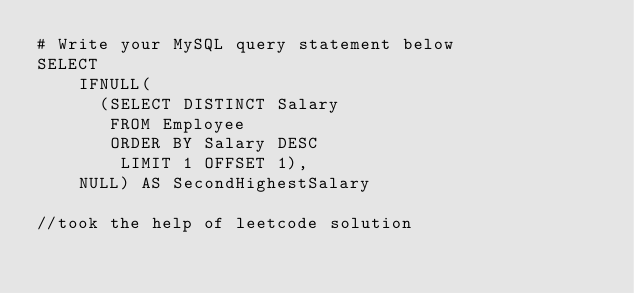Convert code to text. <code><loc_0><loc_0><loc_500><loc_500><_SQL_># Write your MySQL query statement below
SELECT
    IFNULL(
      (SELECT DISTINCT Salary
       FROM Employee
       ORDER BY Salary DESC
        LIMIT 1 OFFSET 1),
    NULL) AS SecondHighestSalary

//took the help of leetcode solution
</code> 